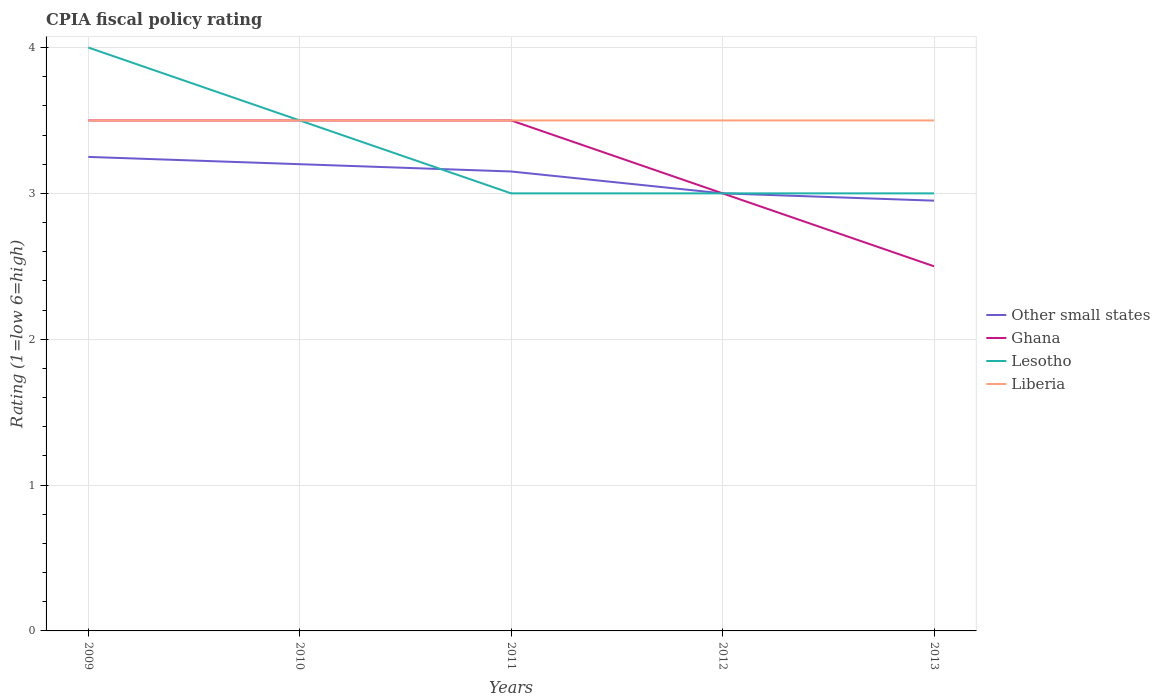How many different coloured lines are there?
Provide a short and direct response. 4. Across all years, what is the maximum CPIA rating in Other small states?
Give a very brief answer. 2.95. In which year was the CPIA rating in Other small states maximum?
Provide a short and direct response. 2013. What is the difference between the highest and the lowest CPIA rating in Other small states?
Offer a very short reply. 3. Is the CPIA rating in Lesotho strictly greater than the CPIA rating in Other small states over the years?
Your response must be concise. No. How many lines are there?
Provide a short and direct response. 4. Does the graph contain any zero values?
Give a very brief answer. No. Does the graph contain grids?
Offer a terse response. Yes. How are the legend labels stacked?
Offer a terse response. Vertical. What is the title of the graph?
Your answer should be very brief. CPIA fiscal policy rating. Does "Cuba" appear as one of the legend labels in the graph?
Offer a terse response. No. What is the Rating (1=low 6=high) of Other small states in 2009?
Give a very brief answer. 3.25. What is the Rating (1=low 6=high) in Other small states in 2010?
Keep it short and to the point. 3.2. What is the Rating (1=low 6=high) of Lesotho in 2010?
Keep it short and to the point. 3.5. What is the Rating (1=low 6=high) of Liberia in 2010?
Make the answer very short. 3.5. What is the Rating (1=low 6=high) of Other small states in 2011?
Keep it short and to the point. 3.15. What is the Rating (1=low 6=high) of Ghana in 2011?
Keep it short and to the point. 3.5. What is the Rating (1=low 6=high) of Liberia in 2011?
Provide a succinct answer. 3.5. What is the Rating (1=low 6=high) in Lesotho in 2012?
Keep it short and to the point. 3. What is the Rating (1=low 6=high) in Liberia in 2012?
Provide a succinct answer. 3.5. What is the Rating (1=low 6=high) of Other small states in 2013?
Your response must be concise. 2.95. What is the Rating (1=low 6=high) in Liberia in 2013?
Offer a very short reply. 3.5. Across all years, what is the maximum Rating (1=low 6=high) in Lesotho?
Provide a succinct answer. 4. Across all years, what is the minimum Rating (1=low 6=high) of Other small states?
Keep it short and to the point. 2.95. Across all years, what is the minimum Rating (1=low 6=high) of Ghana?
Offer a very short reply. 2.5. What is the total Rating (1=low 6=high) of Other small states in the graph?
Offer a very short reply. 15.55. What is the total Rating (1=low 6=high) in Ghana in the graph?
Your answer should be compact. 16. What is the difference between the Rating (1=low 6=high) of Lesotho in 2009 and that in 2010?
Provide a short and direct response. 0.5. What is the difference between the Rating (1=low 6=high) of Liberia in 2009 and that in 2010?
Your answer should be compact. 0. What is the difference between the Rating (1=low 6=high) in Lesotho in 2009 and that in 2011?
Make the answer very short. 1. What is the difference between the Rating (1=low 6=high) in Liberia in 2009 and that in 2011?
Your answer should be very brief. 0. What is the difference between the Rating (1=low 6=high) of Other small states in 2009 and that in 2012?
Your answer should be compact. 0.25. What is the difference between the Rating (1=low 6=high) of Ghana in 2009 and that in 2013?
Give a very brief answer. 1. What is the difference between the Rating (1=low 6=high) of Ghana in 2010 and that in 2011?
Give a very brief answer. 0. What is the difference between the Rating (1=low 6=high) of Lesotho in 2010 and that in 2011?
Provide a succinct answer. 0.5. What is the difference between the Rating (1=low 6=high) of Liberia in 2010 and that in 2011?
Ensure brevity in your answer.  0. What is the difference between the Rating (1=low 6=high) in Other small states in 2010 and that in 2012?
Your response must be concise. 0.2. What is the difference between the Rating (1=low 6=high) of Other small states in 2010 and that in 2013?
Offer a very short reply. 0.25. What is the difference between the Rating (1=low 6=high) of Other small states in 2011 and that in 2012?
Make the answer very short. 0.15. What is the difference between the Rating (1=low 6=high) in Liberia in 2011 and that in 2012?
Ensure brevity in your answer.  0. What is the difference between the Rating (1=low 6=high) of Lesotho in 2011 and that in 2013?
Offer a very short reply. 0. What is the difference between the Rating (1=low 6=high) of Other small states in 2012 and that in 2013?
Your response must be concise. 0.05. What is the difference between the Rating (1=low 6=high) of Liberia in 2012 and that in 2013?
Ensure brevity in your answer.  0. What is the difference between the Rating (1=low 6=high) of Other small states in 2009 and the Rating (1=low 6=high) of Lesotho in 2010?
Your answer should be very brief. -0.25. What is the difference between the Rating (1=low 6=high) of Lesotho in 2009 and the Rating (1=low 6=high) of Liberia in 2010?
Offer a very short reply. 0.5. What is the difference between the Rating (1=low 6=high) of Other small states in 2009 and the Rating (1=low 6=high) of Lesotho in 2011?
Provide a succinct answer. 0.25. What is the difference between the Rating (1=low 6=high) of Ghana in 2009 and the Rating (1=low 6=high) of Liberia in 2011?
Offer a terse response. 0. What is the difference between the Rating (1=low 6=high) of Other small states in 2009 and the Rating (1=low 6=high) of Lesotho in 2012?
Offer a terse response. 0.25. What is the difference between the Rating (1=low 6=high) in Lesotho in 2009 and the Rating (1=low 6=high) in Liberia in 2012?
Provide a succinct answer. 0.5. What is the difference between the Rating (1=low 6=high) in Other small states in 2009 and the Rating (1=low 6=high) in Lesotho in 2013?
Offer a terse response. 0.25. What is the difference between the Rating (1=low 6=high) of Other small states in 2009 and the Rating (1=low 6=high) of Liberia in 2013?
Your answer should be compact. -0.25. What is the difference between the Rating (1=low 6=high) in Lesotho in 2009 and the Rating (1=low 6=high) in Liberia in 2013?
Offer a terse response. 0.5. What is the difference between the Rating (1=low 6=high) in Ghana in 2010 and the Rating (1=low 6=high) in Lesotho in 2011?
Offer a terse response. 0.5. What is the difference between the Rating (1=low 6=high) of Lesotho in 2010 and the Rating (1=low 6=high) of Liberia in 2011?
Provide a succinct answer. 0. What is the difference between the Rating (1=low 6=high) of Other small states in 2010 and the Rating (1=low 6=high) of Ghana in 2012?
Your response must be concise. 0.2. What is the difference between the Rating (1=low 6=high) of Other small states in 2010 and the Rating (1=low 6=high) of Liberia in 2012?
Give a very brief answer. -0.3. What is the difference between the Rating (1=low 6=high) of Ghana in 2010 and the Rating (1=low 6=high) of Liberia in 2012?
Provide a short and direct response. 0. What is the difference between the Rating (1=low 6=high) in Other small states in 2010 and the Rating (1=low 6=high) in Lesotho in 2013?
Keep it short and to the point. 0.2. What is the difference between the Rating (1=low 6=high) in Lesotho in 2010 and the Rating (1=low 6=high) in Liberia in 2013?
Offer a terse response. 0. What is the difference between the Rating (1=low 6=high) in Other small states in 2011 and the Rating (1=low 6=high) in Lesotho in 2012?
Your answer should be compact. 0.15. What is the difference between the Rating (1=low 6=high) of Other small states in 2011 and the Rating (1=low 6=high) of Liberia in 2012?
Give a very brief answer. -0.35. What is the difference between the Rating (1=low 6=high) in Ghana in 2011 and the Rating (1=low 6=high) in Liberia in 2012?
Make the answer very short. 0. What is the difference between the Rating (1=low 6=high) of Other small states in 2011 and the Rating (1=low 6=high) of Ghana in 2013?
Your response must be concise. 0.65. What is the difference between the Rating (1=low 6=high) of Other small states in 2011 and the Rating (1=low 6=high) of Lesotho in 2013?
Your answer should be compact. 0.15. What is the difference between the Rating (1=low 6=high) in Other small states in 2011 and the Rating (1=low 6=high) in Liberia in 2013?
Keep it short and to the point. -0.35. What is the difference between the Rating (1=low 6=high) of Ghana in 2011 and the Rating (1=low 6=high) of Lesotho in 2013?
Keep it short and to the point. 0.5. What is the difference between the Rating (1=low 6=high) in Ghana in 2011 and the Rating (1=low 6=high) in Liberia in 2013?
Ensure brevity in your answer.  0. What is the difference between the Rating (1=low 6=high) of Lesotho in 2011 and the Rating (1=low 6=high) of Liberia in 2013?
Make the answer very short. -0.5. What is the difference between the Rating (1=low 6=high) of Other small states in 2012 and the Rating (1=low 6=high) of Lesotho in 2013?
Ensure brevity in your answer.  0. What is the difference between the Rating (1=low 6=high) in Ghana in 2012 and the Rating (1=low 6=high) in Liberia in 2013?
Your response must be concise. -0.5. What is the difference between the Rating (1=low 6=high) of Lesotho in 2012 and the Rating (1=low 6=high) of Liberia in 2013?
Your answer should be very brief. -0.5. What is the average Rating (1=low 6=high) of Other small states per year?
Your answer should be compact. 3.11. What is the average Rating (1=low 6=high) in Ghana per year?
Offer a terse response. 3.2. What is the average Rating (1=low 6=high) of Lesotho per year?
Ensure brevity in your answer.  3.3. What is the average Rating (1=low 6=high) in Liberia per year?
Provide a succinct answer. 3.5. In the year 2009, what is the difference between the Rating (1=low 6=high) in Other small states and Rating (1=low 6=high) in Lesotho?
Your answer should be very brief. -0.75. In the year 2009, what is the difference between the Rating (1=low 6=high) in Ghana and Rating (1=low 6=high) in Lesotho?
Make the answer very short. -0.5. In the year 2009, what is the difference between the Rating (1=low 6=high) in Ghana and Rating (1=low 6=high) in Liberia?
Provide a short and direct response. 0. In the year 2009, what is the difference between the Rating (1=low 6=high) of Lesotho and Rating (1=low 6=high) of Liberia?
Make the answer very short. 0.5. In the year 2010, what is the difference between the Rating (1=low 6=high) of Other small states and Rating (1=low 6=high) of Ghana?
Ensure brevity in your answer.  -0.3. In the year 2010, what is the difference between the Rating (1=low 6=high) of Ghana and Rating (1=low 6=high) of Lesotho?
Provide a short and direct response. 0. In the year 2010, what is the difference between the Rating (1=low 6=high) in Lesotho and Rating (1=low 6=high) in Liberia?
Provide a short and direct response. 0. In the year 2011, what is the difference between the Rating (1=low 6=high) in Other small states and Rating (1=low 6=high) in Ghana?
Make the answer very short. -0.35. In the year 2011, what is the difference between the Rating (1=low 6=high) of Other small states and Rating (1=low 6=high) of Lesotho?
Your answer should be compact. 0.15. In the year 2011, what is the difference between the Rating (1=low 6=high) in Other small states and Rating (1=low 6=high) in Liberia?
Your answer should be compact. -0.35. In the year 2011, what is the difference between the Rating (1=low 6=high) of Lesotho and Rating (1=low 6=high) of Liberia?
Offer a terse response. -0.5. In the year 2012, what is the difference between the Rating (1=low 6=high) of Other small states and Rating (1=low 6=high) of Lesotho?
Offer a terse response. 0. In the year 2012, what is the difference between the Rating (1=low 6=high) in Other small states and Rating (1=low 6=high) in Liberia?
Your response must be concise. -0.5. In the year 2013, what is the difference between the Rating (1=low 6=high) in Other small states and Rating (1=low 6=high) in Ghana?
Provide a short and direct response. 0.45. In the year 2013, what is the difference between the Rating (1=low 6=high) in Other small states and Rating (1=low 6=high) in Lesotho?
Offer a terse response. -0.05. In the year 2013, what is the difference between the Rating (1=low 6=high) in Other small states and Rating (1=low 6=high) in Liberia?
Provide a short and direct response. -0.55. In the year 2013, what is the difference between the Rating (1=low 6=high) in Ghana and Rating (1=low 6=high) in Liberia?
Provide a short and direct response. -1. What is the ratio of the Rating (1=low 6=high) of Other small states in 2009 to that in 2010?
Your answer should be very brief. 1.02. What is the ratio of the Rating (1=low 6=high) of Ghana in 2009 to that in 2010?
Give a very brief answer. 1. What is the ratio of the Rating (1=low 6=high) in Lesotho in 2009 to that in 2010?
Ensure brevity in your answer.  1.14. What is the ratio of the Rating (1=low 6=high) of Liberia in 2009 to that in 2010?
Ensure brevity in your answer.  1. What is the ratio of the Rating (1=low 6=high) in Other small states in 2009 to that in 2011?
Offer a very short reply. 1.03. What is the ratio of the Rating (1=low 6=high) in Ghana in 2009 to that in 2011?
Provide a succinct answer. 1. What is the ratio of the Rating (1=low 6=high) in Lesotho in 2009 to that in 2011?
Your answer should be very brief. 1.33. What is the ratio of the Rating (1=low 6=high) in Liberia in 2009 to that in 2011?
Your answer should be compact. 1. What is the ratio of the Rating (1=low 6=high) in Lesotho in 2009 to that in 2012?
Keep it short and to the point. 1.33. What is the ratio of the Rating (1=low 6=high) in Other small states in 2009 to that in 2013?
Offer a very short reply. 1.1. What is the ratio of the Rating (1=low 6=high) of Other small states in 2010 to that in 2011?
Offer a very short reply. 1.02. What is the ratio of the Rating (1=low 6=high) of Lesotho in 2010 to that in 2011?
Your response must be concise. 1.17. What is the ratio of the Rating (1=low 6=high) in Liberia in 2010 to that in 2011?
Your answer should be very brief. 1. What is the ratio of the Rating (1=low 6=high) in Other small states in 2010 to that in 2012?
Your answer should be very brief. 1.07. What is the ratio of the Rating (1=low 6=high) of Ghana in 2010 to that in 2012?
Ensure brevity in your answer.  1.17. What is the ratio of the Rating (1=low 6=high) in Other small states in 2010 to that in 2013?
Provide a succinct answer. 1.08. What is the ratio of the Rating (1=low 6=high) in Ghana in 2010 to that in 2013?
Ensure brevity in your answer.  1.4. What is the ratio of the Rating (1=low 6=high) in Lesotho in 2010 to that in 2013?
Make the answer very short. 1.17. What is the ratio of the Rating (1=low 6=high) of Liberia in 2010 to that in 2013?
Keep it short and to the point. 1. What is the ratio of the Rating (1=low 6=high) in Other small states in 2011 to that in 2012?
Provide a short and direct response. 1.05. What is the ratio of the Rating (1=low 6=high) of Ghana in 2011 to that in 2012?
Your answer should be compact. 1.17. What is the ratio of the Rating (1=low 6=high) of Lesotho in 2011 to that in 2012?
Provide a short and direct response. 1. What is the ratio of the Rating (1=low 6=high) of Liberia in 2011 to that in 2012?
Your response must be concise. 1. What is the ratio of the Rating (1=low 6=high) of Other small states in 2011 to that in 2013?
Your answer should be very brief. 1.07. What is the ratio of the Rating (1=low 6=high) in Lesotho in 2011 to that in 2013?
Your answer should be very brief. 1. What is the ratio of the Rating (1=low 6=high) of Liberia in 2011 to that in 2013?
Keep it short and to the point. 1. What is the ratio of the Rating (1=low 6=high) of Other small states in 2012 to that in 2013?
Offer a very short reply. 1.02. What is the difference between the highest and the second highest Rating (1=low 6=high) in Lesotho?
Provide a succinct answer. 0.5. What is the difference between the highest and the second highest Rating (1=low 6=high) of Liberia?
Your response must be concise. 0. What is the difference between the highest and the lowest Rating (1=low 6=high) of Other small states?
Your response must be concise. 0.3. What is the difference between the highest and the lowest Rating (1=low 6=high) of Ghana?
Provide a succinct answer. 1. What is the difference between the highest and the lowest Rating (1=low 6=high) in Lesotho?
Your answer should be very brief. 1. 